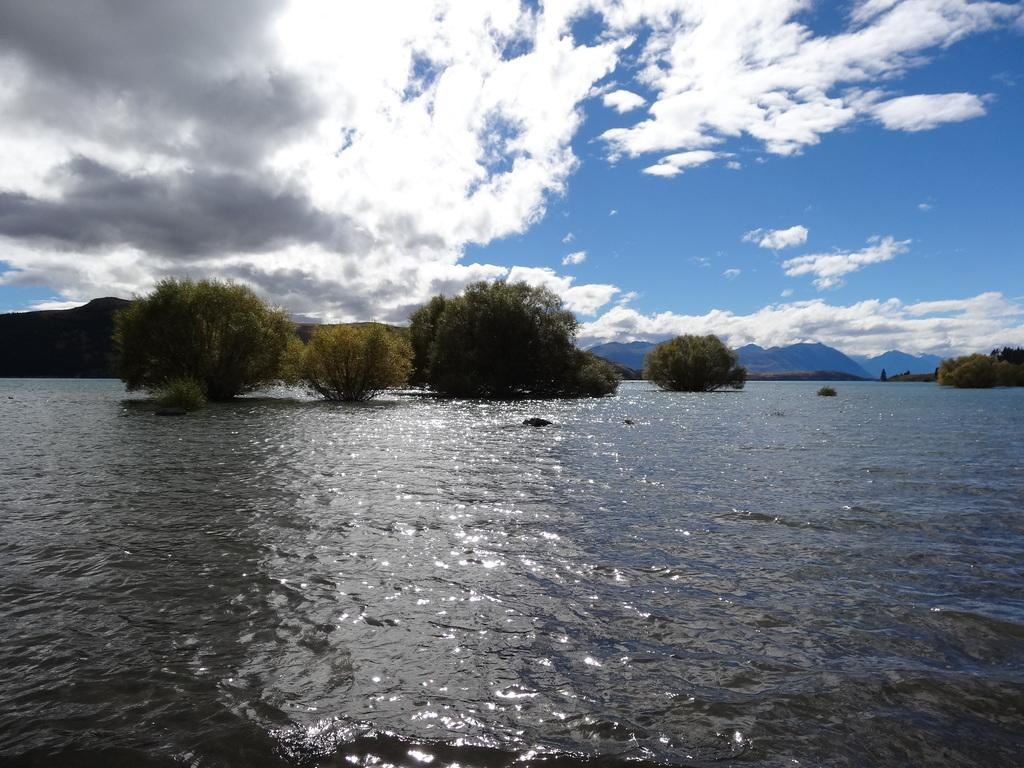What is the primary element in the image? There is water in the image. What can be seen in the background of the image? There are trees and hills visible in the background of the image. What is visible in the sky in the image? Clouds are present in the sky in the image. How many details can be seen on the cent in the image? There is no cent present in the image. Can you describe the kiss between the two people in the image? There are no people or kisses depicted in the image. 